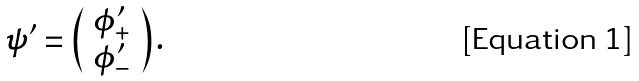Convert formula to latex. <formula><loc_0><loc_0><loc_500><loc_500>\psi ^ { \prime } = \left ( \begin{array} { l } \phi _ { + } ^ { \prime } \\ \phi _ { - } ^ { \prime } \end{array} \right ) .</formula> 